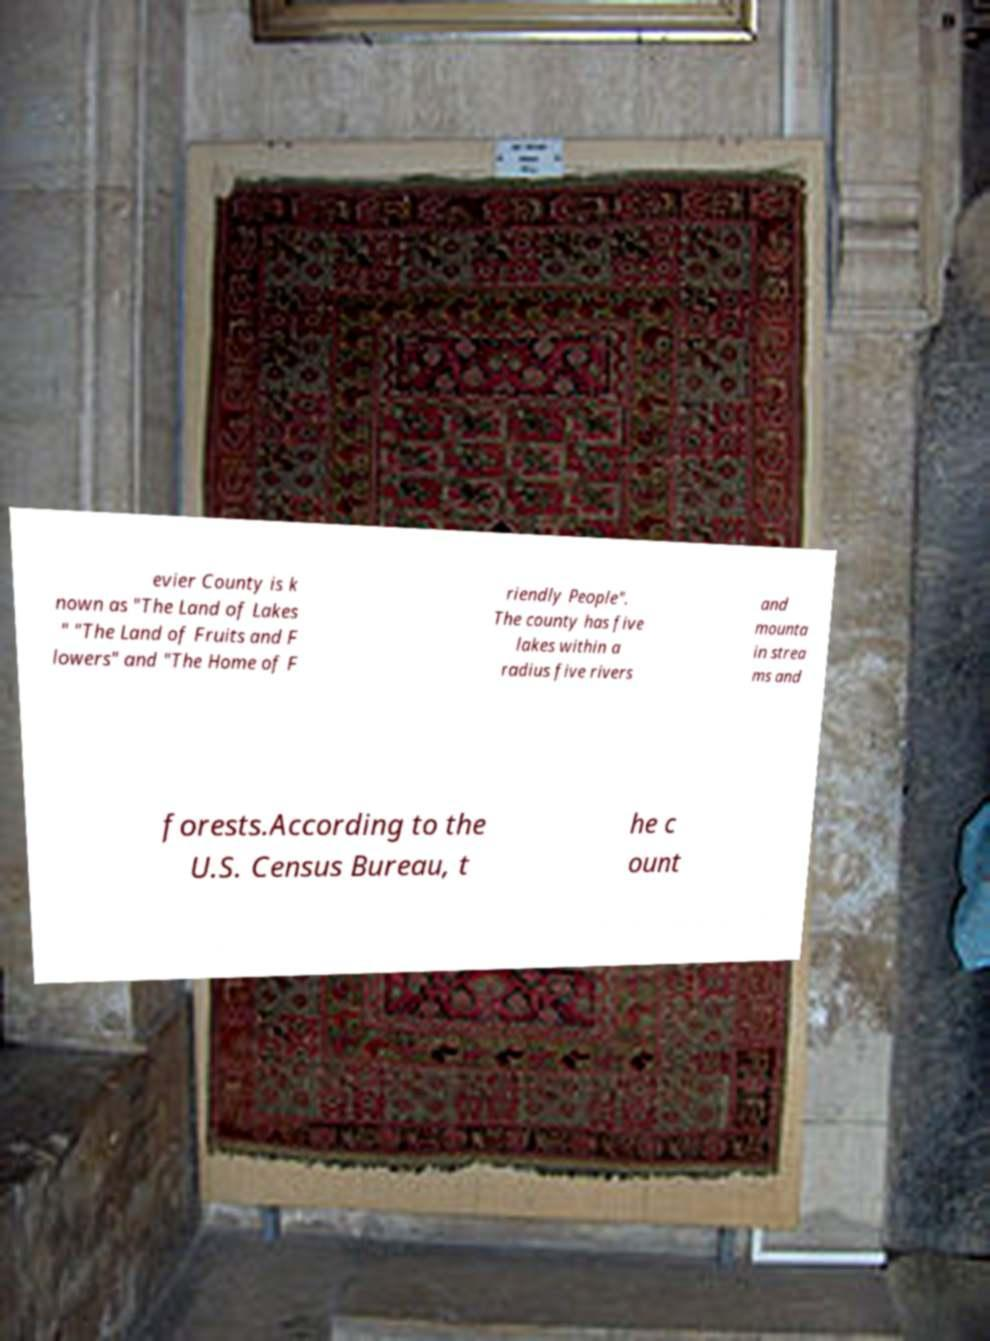Please read and relay the text visible in this image. What does it say? evier County is k nown as "The Land of Lakes " "The Land of Fruits and F lowers" and "The Home of F riendly People". The county has five lakes within a radius five rivers and mounta in strea ms and forests.According to the U.S. Census Bureau, t he c ount 